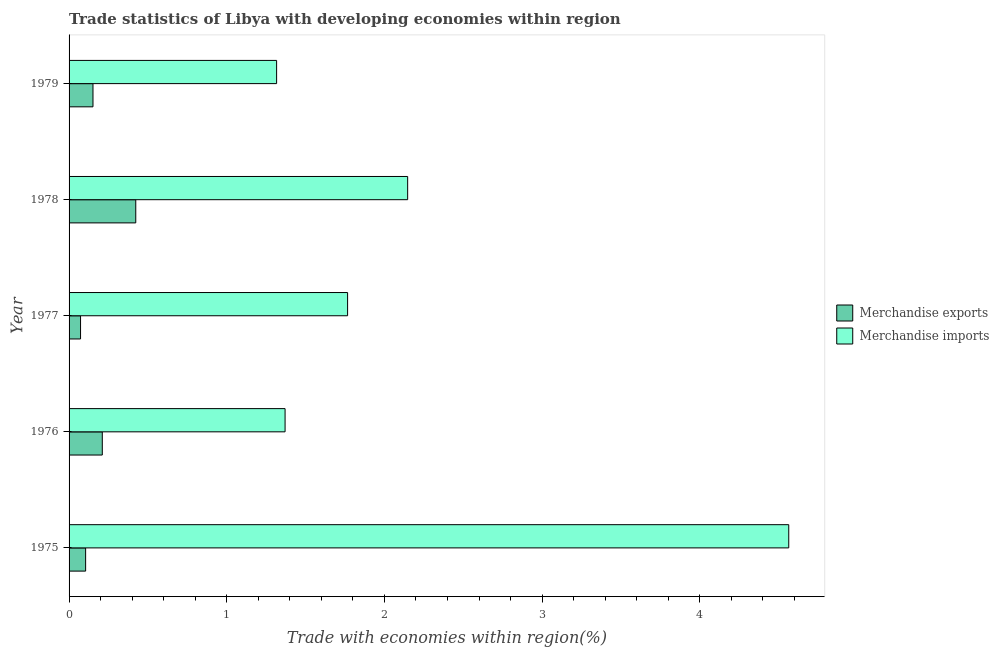How many different coloured bars are there?
Give a very brief answer. 2. How many groups of bars are there?
Your answer should be compact. 5. Are the number of bars per tick equal to the number of legend labels?
Make the answer very short. Yes. Are the number of bars on each tick of the Y-axis equal?
Provide a short and direct response. Yes. How many bars are there on the 2nd tick from the bottom?
Provide a short and direct response. 2. What is the label of the 4th group of bars from the top?
Your answer should be very brief. 1976. What is the merchandise exports in 1975?
Make the answer very short. 0.1. Across all years, what is the maximum merchandise exports?
Your answer should be very brief. 0.42. Across all years, what is the minimum merchandise exports?
Offer a terse response. 0.07. In which year was the merchandise exports maximum?
Your answer should be compact. 1978. In which year was the merchandise exports minimum?
Your answer should be very brief. 1977. What is the total merchandise imports in the graph?
Provide a short and direct response. 11.16. What is the difference between the merchandise exports in 1976 and that in 1977?
Your answer should be compact. 0.14. What is the difference between the merchandise exports in 1979 and the merchandise imports in 1977?
Provide a succinct answer. -1.61. What is the average merchandise imports per year?
Keep it short and to the point. 2.23. In the year 1978, what is the difference between the merchandise exports and merchandise imports?
Ensure brevity in your answer.  -1.72. In how many years, is the merchandise exports greater than 1 %?
Offer a terse response. 0. What is the ratio of the merchandise imports in 1976 to that in 1978?
Keep it short and to the point. 0.64. What is the difference between the highest and the second highest merchandise exports?
Provide a short and direct response. 0.21. What is the difference between the highest and the lowest merchandise exports?
Provide a succinct answer. 0.35. In how many years, is the merchandise imports greater than the average merchandise imports taken over all years?
Make the answer very short. 1. What does the 2nd bar from the top in 1979 represents?
Make the answer very short. Merchandise exports. What does the 1st bar from the bottom in 1979 represents?
Provide a succinct answer. Merchandise exports. How many years are there in the graph?
Your answer should be compact. 5. Are the values on the major ticks of X-axis written in scientific E-notation?
Provide a short and direct response. No. Does the graph contain any zero values?
Keep it short and to the point. No. Does the graph contain grids?
Offer a very short reply. No. Where does the legend appear in the graph?
Provide a short and direct response. Center right. How are the legend labels stacked?
Offer a terse response. Vertical. What is the title of the graph?
Keep it short and to the point. Trade statistics of Libya with developing economies within region. What is the label or title of the X-axis?
Give a very brief answer. Trade with economies within region(%). What is the label or title of the Y-axis?
Your answer should be very brief. Year. What is the Trade with economies within region(%) in Merchandise exports in 1975?
Offer a very short reply. 0.1. What is the Trade with economies within region(%) in Merchandise imports in 1975?
Your answer should be compact. 4.56. What is the Trade with economies within region(%) of Merchandise exports in 1976?
Offer a terse response. 0.21. What is the Trade with economies within region(%) of Merchandise imports in 1976?
Offer a terse response. 1.37. What is the Trade with economies within region(%) of Merchandise exports in 1977?
Offer a terse response. 0.07. What is the Trade with economies within region(%) in Merchandise imports in 1977?
Provide a succinct answer. 1.77. What is the Trade with economies within region(%) in Merchandise exports in 1978?
Give a very brief answer. 0.42. What is the Trade with economies within region(%) in Merchandise imports in 1978?
Keep it short and to the point. 2.15. What is the Trade with economies within region(%) in Merchandise exports in 1979?
Your response must be concise. 0.15. What is the Trade with economies within region(%) in Merchandise imports in 1979?
Offer a very short reply. 1.32. Across all years, what is the maximum Trade with economies within region(%) in Merchandise exports?
Offer a terse response. 0.42. Across all years, what is the maximum Trade with economies within region(%) of Merchandise imports?
Your answer should be very brief. 4.56. Across all years, what is the minimum Trade with economies within region(%) of Merchandise exports?
Provide a short and direct response. 0.07. Across all years, what is the minimum Trade with economies within region(%) in Merchandise imports?
Give a very brief answer. 1.32. What is the total Trade with economies within region(%) in Merchandise imports in the graph?
Offer a very short reply. 11.16. What is the difference between the Trade with economies within region(%) of Merchandise exports in 1975 and that in 1976?
Offer a terse response. -0.11. What is the difference between the Trade with economies within region(%) of Merchandise imports in 1975 and that in 1976?
Make the answer very short. 3.19. What is the difference between the Trade with economies within region(%) of Merchandise exports in 1975 and that in 1977?
Your answer should be very brief. 0.03. What is the difference between the Trade with economies within region(%) in Merchandise imports in 1975 and that in 1977?
Make the answer very short. 2.8. What is the difference between the Trade with economies within region(%) in Merchandise exports in 1975 and that in 1978?
Provide a succinct answer. -0.32. What is the difference between the Trade with economies within region(%) of Merchandise imports in 1975 and that in 1978?
Provide a short and direct response. 2.42. What is the difference between the Trade with economies within region(%) of Merchandise exports in 1975 and that in 1979?
Provide a short and direct response. -0.05. What is the difference between the Trade with economies within region(%) in Merchandise imports in 1975 and that in 1979?
Keep it short and to the point. 3.25. What is the difference between the Trade with economies within region(%) in Merchandise exports in 1976 and that in 1977?
Give a very brief answer. 0.14. What is the difference between the Trade with economies within region(%) in Merchandise imports in 1976 and that in 1977?
Offer a very short reply. -0.4. What is the difference between the Trade with economies within region(%) in Merchandise exports in 1976 and that in 1978?
Offer a terse response. -0.21. What is the difference between the Trade with economies within region(%) of Merchandise imports in 1976 and that in 1978?
Provide a succinct answer. -0.78. What is the difference between the Trade with economies within region(%) in Merchandise exports in 1976 and that in 1979?
Give a very brief answer. 0.06. What is the difference between the Trade with economies within region(%) in Merchandise imports in 1976 and that in 1979?
Your answer should be very brief. 0.05. What is the difference between the Trade with economies within region(%) in Merchandise exports in 1977 and that in 1978?
Your answer should be compact. -0.35. What is the difference between the Trade with economies within region(%) in Merchandise imports in 1977 and that in 1978?
Your answer should be compact. -0.38. What is the difference between the Trade with economies within region(%) of Merchandise exports in 1977 and that in 1979?
Make the answer very short. -0.08. What is the difference between the Trade with economies within region(%) of Merchandise imports in 1977 and that in 1979?
Give a very brief answer. 0.45. What is the difference between the Trade with economies within region(%) in Merchandise exports in 1978 and that in 1979?
Your response must be concise. 0.27. What is the difference between the Trade with economies within region(%) of Merchandise imports in 1978 and that in 1979?
Provide a succinct answer. 0.83. What is the difference between the Trade with economies within region(%) of Merchandise exports in 1975 and the Trade with economies within region(%) of Merchandise imports in 1976?
Offer a terse response. -1.26. What is the difference between the Trade with economies within region(%) in Merchandise exports in 1975 and the Trade with economies within region(%) in Merchandise imports in 1977?
Offer a very short reply. -1.66. What is the difference between the Trade with economies within region(%) of Merchandise exports in 1975 and the Trade with economies within region(%) of Merchandise imports in 1978?
Your response must be concise. -2.04. What is the difference between the Trade with economies within region(%) of Merchandise exports in 1975 and the Trade with economies within region(%) of Merchandise imports in 1979?
Your answer should be compact. -1.21. What is the difference between the Trade with economies within region(%) in Merchandise exports in 1976 and the Trade with economies within region(%) in Merchandise imports in 1977?
Your answer should be very brief. -1.56. What is the difference between the Trade with economies within region(%) in Merchandise exports in 1976 and the Trade with economies within region(%) in Merchandise imports in 1978?
Offer a terse response. -1.94. What is the difference between the Trade with economies within region(%) of Merchandise exports in 1976 and the Trade with economies within region(%) of Merchandise imports in 1979?
Offer a terse response. -1.11. What is the difference between the Trade with economies within region(%) of Merchandise exports in 1977 and the Trade with economies within region(%) of Merchandise imports in 1978?
Your response must be concise. -2.07. What is the difference between the Trade with economies within region(%) of Merchandise exports in 1977 and the Trade with economies within region(%) of Merchandise imports in 1979?
Your answer should be compact. -1.24. What is the difference between the Trade with economies within region(%) of Merchandise exports in 1978 and the Trade with economies within region(%) of Merchandise imports in 1979?
Ensure brevity in your answer.  -0.89. What is the average Trade with economies within region(%) in Merchandise exports per year?
Make the answer very short. 0.19. What is the average Trade with economies within region(%) of Merchandise imports per year?
Keep it short and to the point. 2.23. In the year 1975, what is the difference between the Trade with economies within region(%) of Merchandise exports and Trade with economies within region(%) of Merchandise imports?
Offer a terse response. -4.46. In the year 1976, what is the difference between the Trade with economies within region(%) in Merchandise exports and Trade with economies within region(%) in Merchandise imports?
Your answer should be very brief. -1.16. In the year 1977, what is the difference between the Trade with economies within region(%) in Merchandise exports and Trade with economies within region(%) in Merchandise imports?
Offer a terse response. -1.69. In the year 1978, what is the difference between the Trade with economies within region(%) in Merchandise exports and Trade with economies within region(%) in Merchandise imports?
Your response must be concise. -1.72. In the year 1979, what is the difference between the Trade with economies within region(%) of Merchandise exports and Trade with economies within region(%) of Merchandise imports?
Provide a short and direct response. -1.16. What is the ratio of the Trade with economies within region(%) of Merchandise exports in 1975 to that in 1976?
Give a very brief answer. 0.5. What is the ratio of the Trade with economies within region(%) of Merchandise imports in 1975 to that in 1976?
Offer a very short reply. 3.33. What is the ratio of the Trade with economies within region(%) in Merchandise exports in 1975 to that in 1977?
Your response must be concise. 1.44. What is the ratio of the Trade with economies within region(%) in Merchandise imports in 1975 to that in 1977?
Ensure brevity in your answer.  2.58. What is the ratio of the Trade with economies within region(%) in Merchandise exports in 1975 to that in 1978?
Keep it short and to the point. 0.25. What is the ratio of the Trade with economies within region(%) of Merchandise imports in 1975 to that in 1978?
Make the answer very short. 2.13. What is the ratio of the Trade with economies within region(%) of Merchandise exports in 1975 to that in 1979?
Give a very brief answer. 0.69. What is the ratio of the Trade with economies within region(%) of Merchandise imports in 1975 to that in 1979?
Provide a short and direct response. 3.47. What is the ratio of the Trade with economies within region(%) of Merchandise exports in 1976 to that in 1977?
Keep it short and to the point. 2.9. What is the ratio of the Trade with economies within region(%) in Merchandise imports in 1976 to that in 1977?
Provide a short and direct response. 0.78. What is the ratio of the Trade with economies within region(%) in Merchandise exports in 1976 to that in 1978?
Offer a very short reply. 0.5. What is the ratio of the Trade with economies within region(%) of Merchandise imports in 1976 to that in 1978?
Offer a very short reply. 0.64. What is the ratio of the Trade with economies within region(%) in Merchandise exports in 1976 to that in 1979?
Provide a succinct answer. 1.39. What is the ratio of the Trade with economies within region(%) of Merchandise imports in 1976 to that in 1979?
Offer a terse response. 1.04. What is the ratio of the Trade with economies within region(%) of Merchandise exports in 1977 to that in 1978?
Provide a short and direct response. 0.17. What is the ratio of the Trade with economies within region(%) of Merchandise imports in 1977 to that in 1978?
Provide a succinct answer. 0.82. What is the ratio of the Trade with economies within region(%) in Merchandise exports in 1977 to that in 1979?
Keep it short and to the point. 0.48. What is the ratio of the Trade with economies within region(%) in Merchandise imports in 1977 to that in 1979?
Provide a succinct answer. 1.34. What is the ratio of the Trade with economies within region(%) in Merchandise exports in 1978 to that in 1979?
Your response must be concise. 2.79. What is the ratio of the Trade with economies within region(%) of Merchandise imports in 1978 to that in 1979?
Your answer should be compact. 1.63. What is the difference between the highest and the second highest Trade with economies within region(%) of Merchandise exports?
Your answer should be compact. 0.21. What is the difference between the highest and the second highest Trade with economies within region(%) in Merchandise imports?
Your answer should be compact. 2.42. What is the difference between the highest and the lowest Trade with economies within region(%) of Merchandise exports?
Ensure brevity in your answer.  0.35. What is the difference between the highest and the lowest Trade with economies within region(%) in Merchandise imports?
Provide a succinct answer. 3.25. 